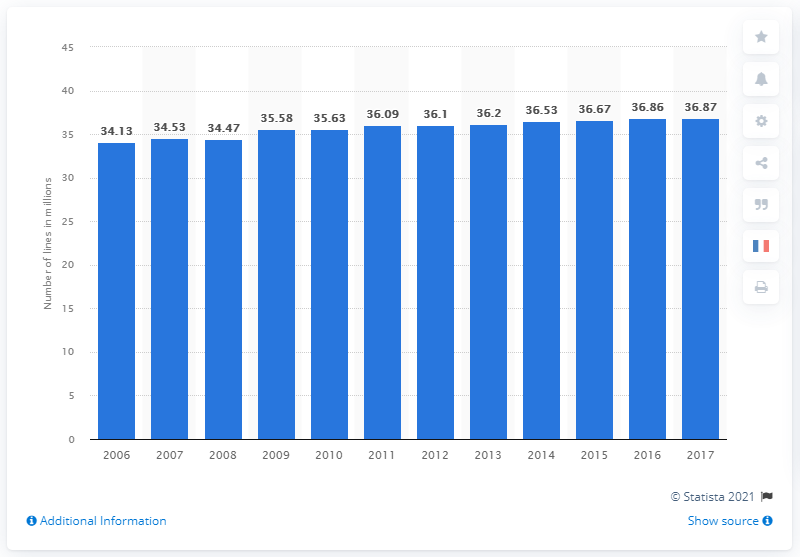Specify some key components in this picture. In the first quarter of 2017, there were 36,870 fixed telephone lines in France. 